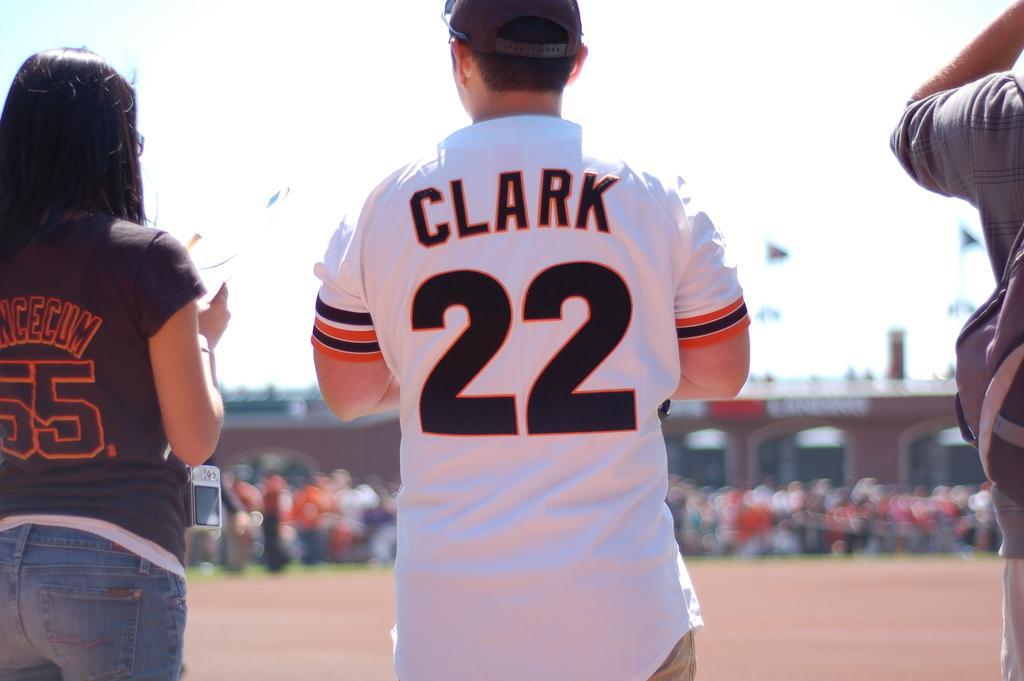How would you summarize this image in a sentence or two? In this picture I can observe three members standing on the land. The background is blurred. 